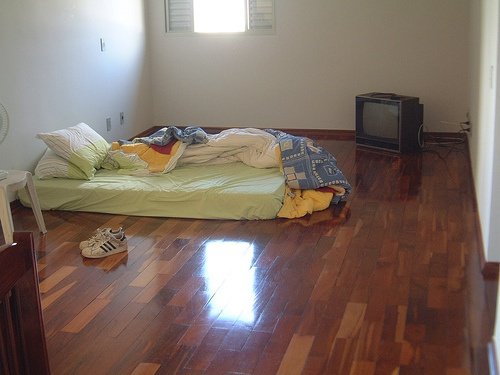Describe the objects in this image and their specific colors. I can see bed in gray, olive, and darkgray tones, chair in gray, black, maroon, and brown tones, tv in gray and black tones, and chair in gray tones in this image. 